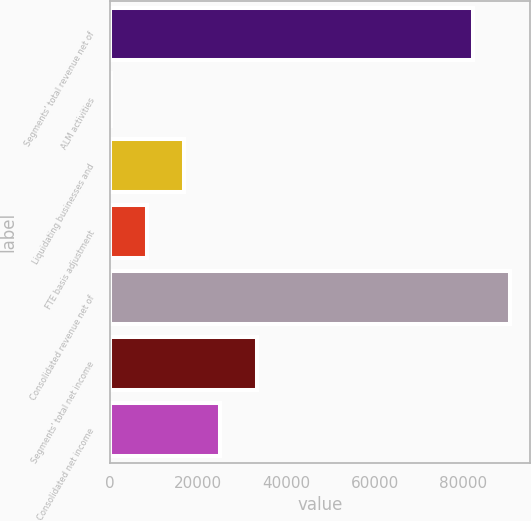Convert chart. <chart><loc_0><loc_0><loc_500><loc_500><bar_chart><fcel>Segments' total revenue net of<fcel>ALM activities<fcel>Liquidating businesses and<fcel>FTE basis adjustment<fcel>Consolidated revenue net of<fcel>Segments' total net income<fcel>Consolidated net income<nl><fcel>82193<fcel>208<fcel>16759.4<fcel>8483.7<fcel>90468.7<fcel>33310.8<fcel>25035.1<nl></chart> 